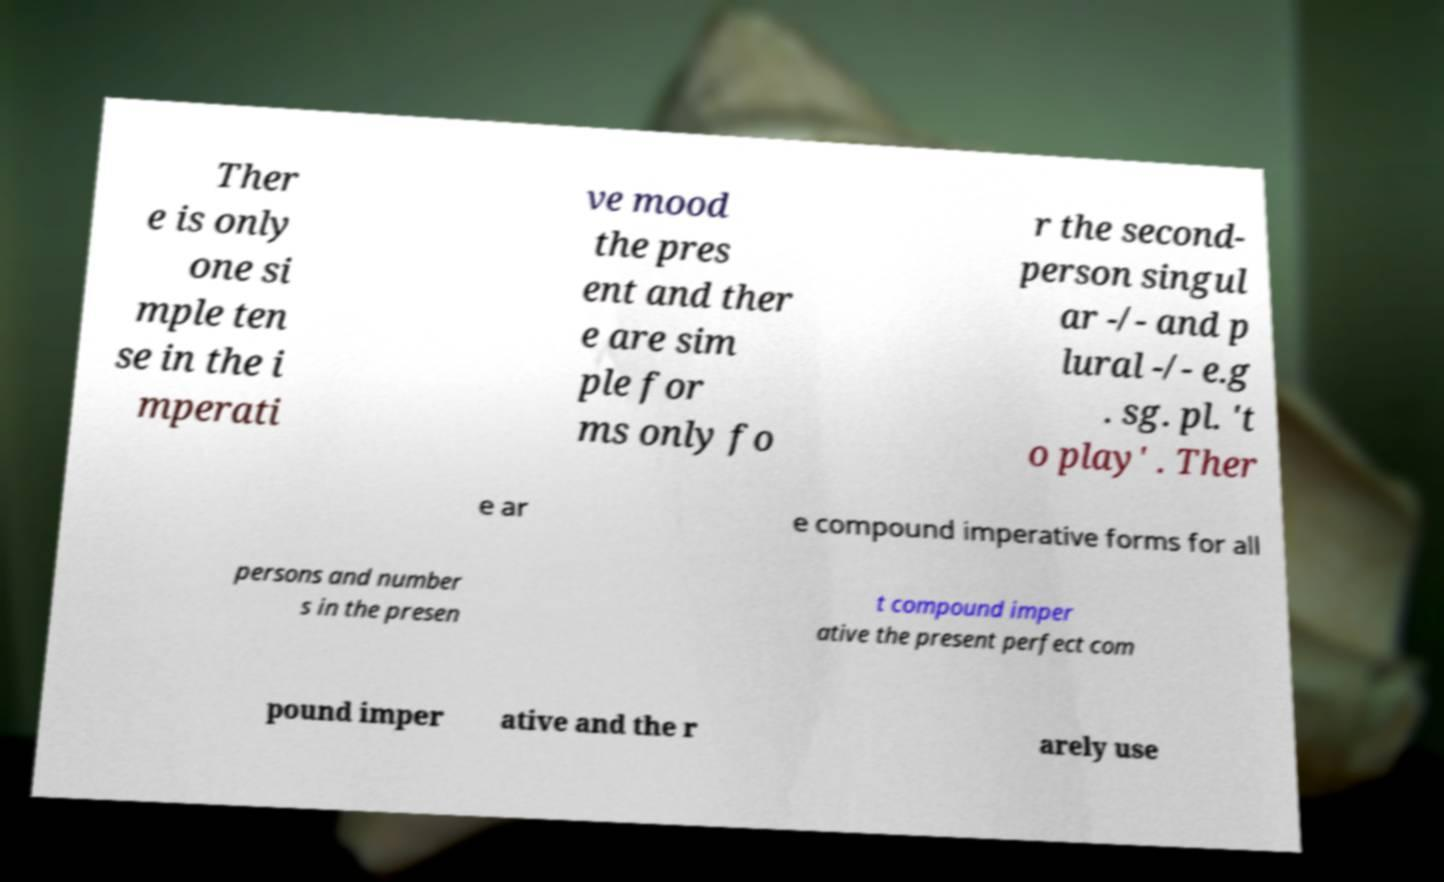Please identify and transcribe the text found in this image. Ther e is only one si mple ten se in the i mperati ve mood the pres ent and ther e are sim ple for ms only fo r the second- person singul ar -/- and p lural -/- e.g . sg. pl. 't o play' . Ther e ar e compound imperative forms for all persons and number s in the presen t compound imper ative the present perfect com pound imper ative and the r arely use 